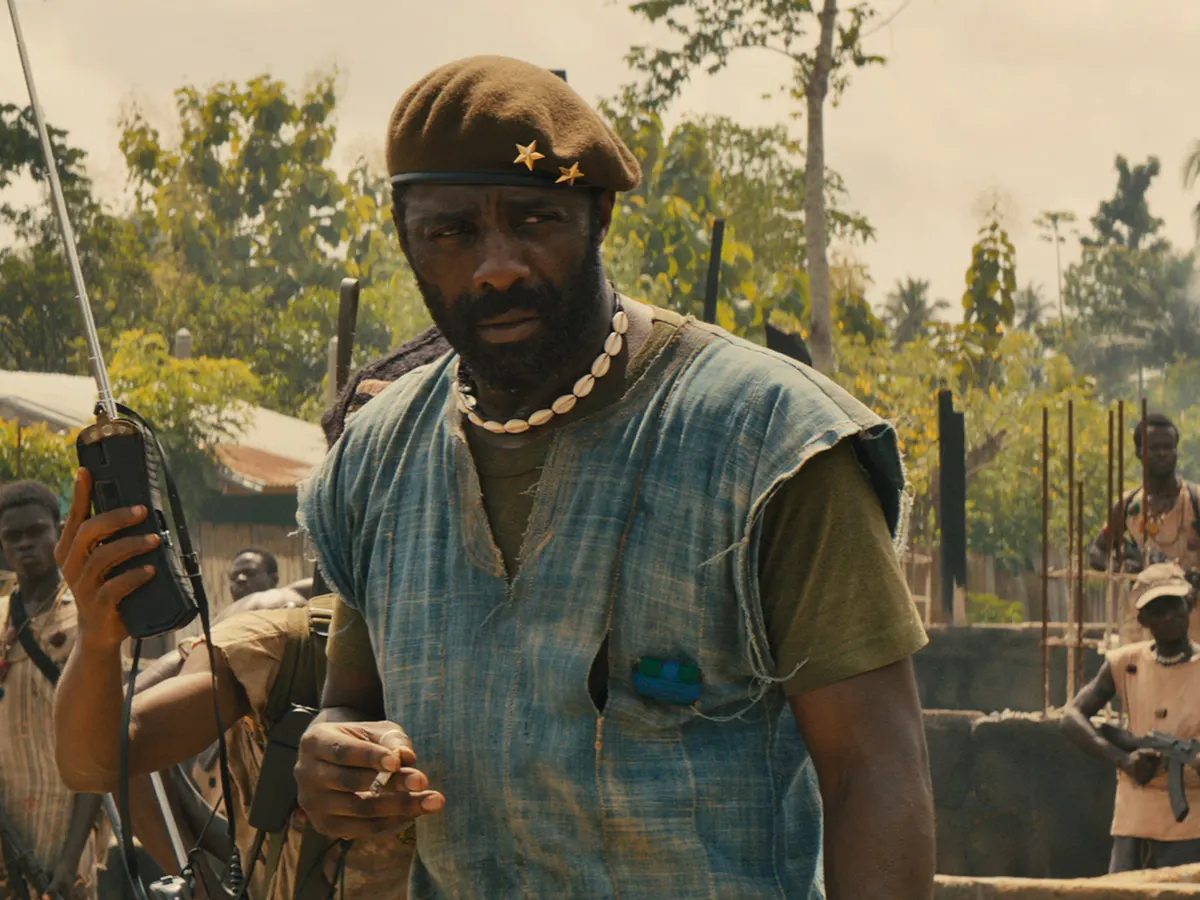Describe in detail the attire and gear carried by the main figure and any possible significance. The main figure is dressed in a rugged, sleeveless blue shirt layered over a green vest. The clothing choice reflects the harsh and demanding environment, indicating a need for mobility and functionality. He dons a green beret with two gold stars, a possible insignia of rank or affiliation. Around his neck is a necklace made of white beads, which might hold personal or cultural significance. He holds a walkie-talkie in his right hand, signifying his role in communication and command, and carries a firearm slung over his left shoulder, underlining the constant readiness for combat. These elements together paint a picture of a leader deeply embedded in a militant environment, addressing both practical and symbolic needs. 